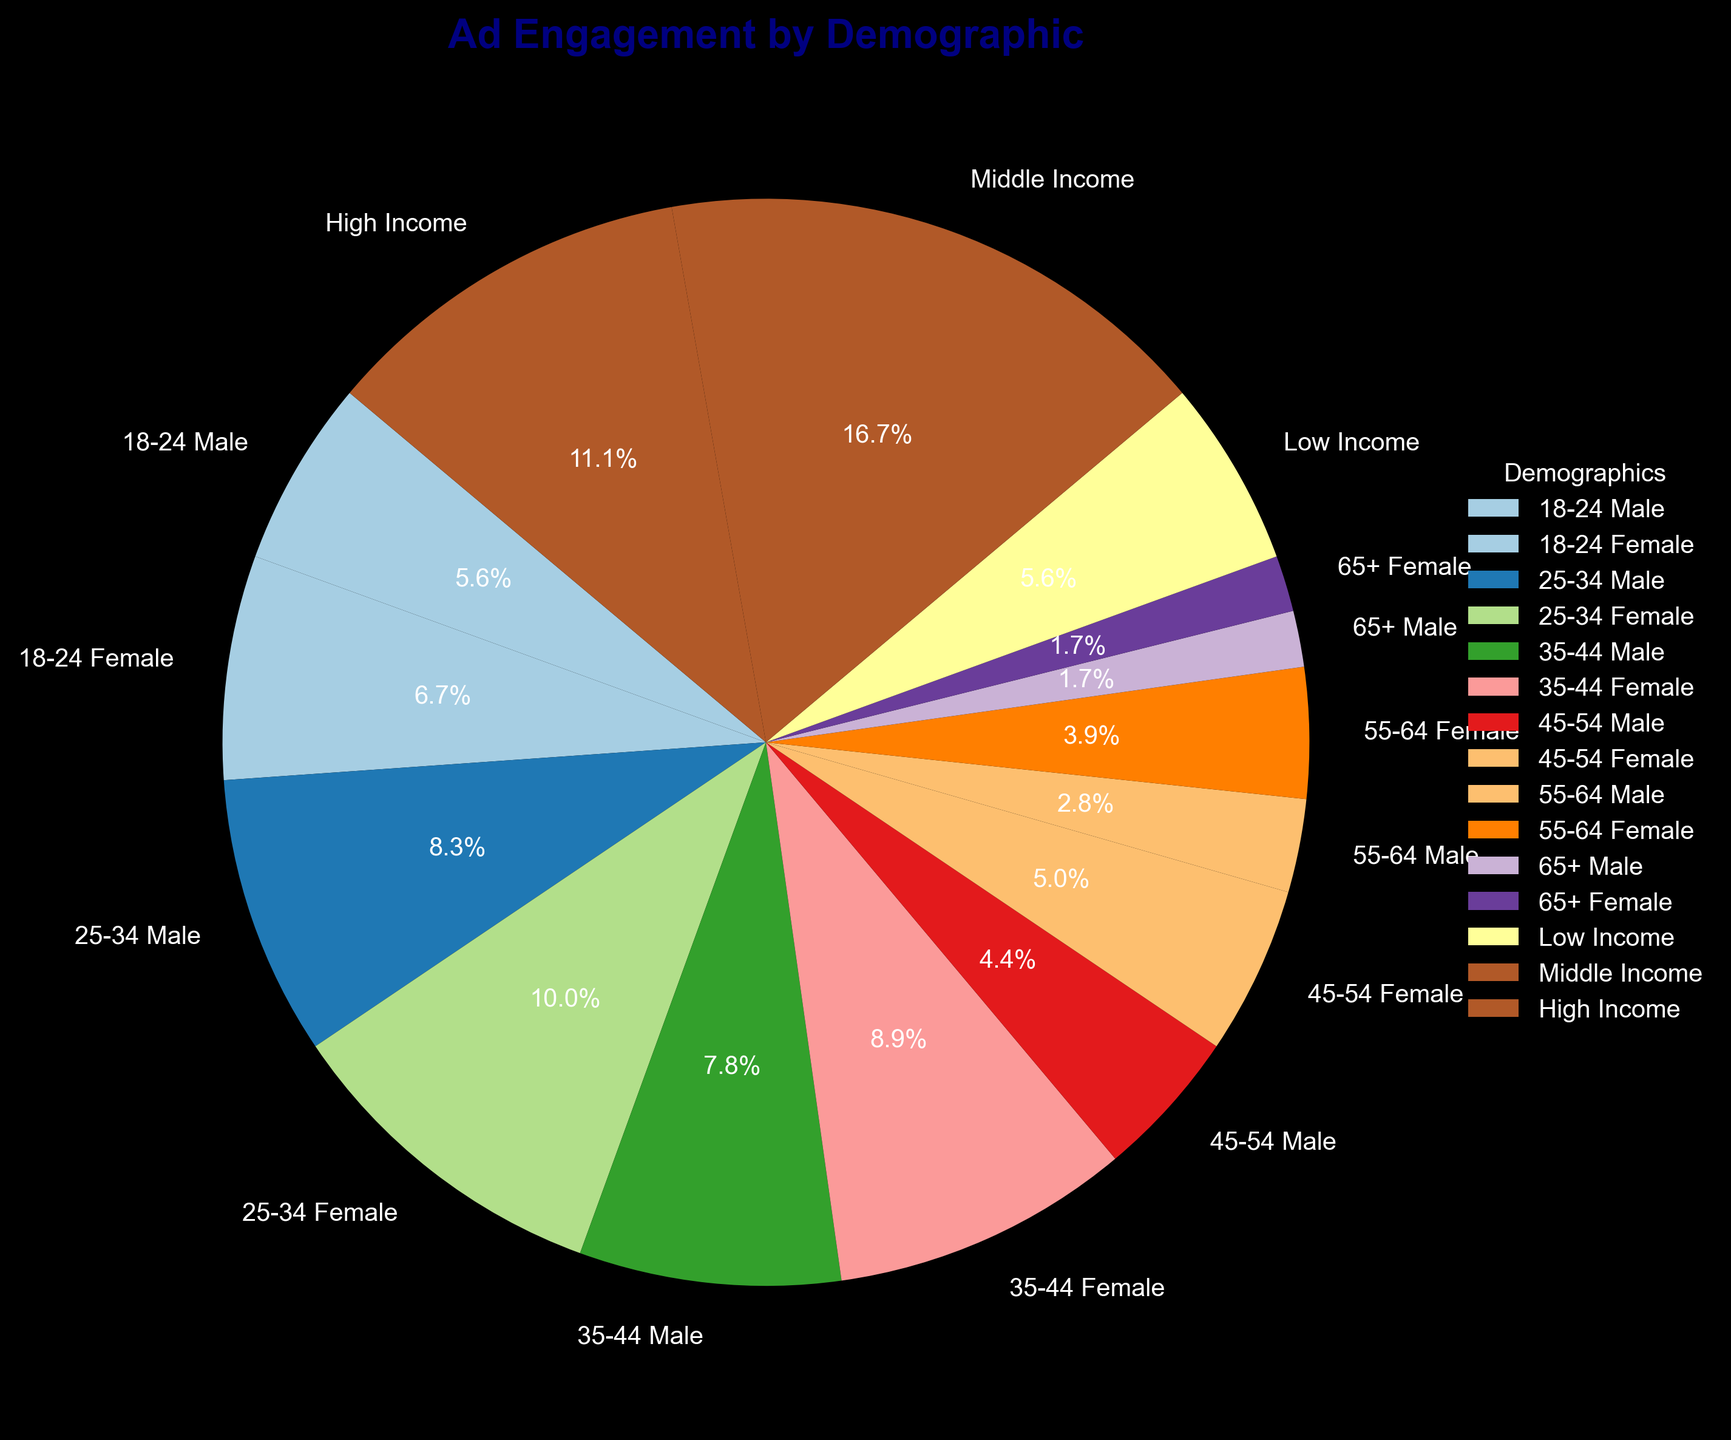Which demographic has the highest ad engagement? Identify the wedge with the largest percentage, which is "25-34 Female" with 18%.
Answer: 25-34 Female Which age group has the lowest ad engagement, and what is its percentage? Identify the age group and gender with the smallest wedge, which is "65+ Male" and "65+ Female", both with 3%.
Answer: 65+ Male and Female, 3% What's the combined ad engagement percentage for males aged 18-34? Sum up the percentage for "18-24 Male" (10%), "25-34 Male" (15%): 10% + 15% = 25%.
Answer: 25% How does the ad engagement of females aged 25-34 compare to that of females aged 35-44? Compare "25-34 Female" (18%) and "35-44 Female" (16%): 18% > 16%.
Answer: 25-34 Female has higher engagement What is the total percentage of ad engagement for females aged 18-44? Sum up percentages for "18-24 Female" (12%), "25-34 Female" (18%), and "35-44 Female" (16%): 12% + 18% + 16% = 46%.
Answer: 46% Compare the total ad engagement percentages of males and females. Sum up percentages for all male and female demographics: Males (58%) and Females (65%). Compare both sums: 58% < 65%.
Answer: Females have higher engagement What is the ad engagement percentage difference between the highest (25-34 Female) and the lowest (65+ Male) demographics? Calculate the percentage difference: 18% - 3% = 15%.
Answer: 15% What is the combined ad engagement for the "Low Income" and "High Income" groups? Sum up the percentage for "Low Income" (10%) and "High Income" (20%): 10% + 20% = 30%.
Answer: 30% What visual characteristic helps in easily identifying the demographic with 3% ad engagement? Identify the smallest wedges in the pie chart, corresponding to "65+ Male" and "65+ Female". Being the smallest pieces makes them distinctly noticeable.
Answer: Smallest wedges How does the ad engagement for Middle Income compare with the combined ad engagement of the 55-64 age group? Compare "Middle Income" (30%) with the sum of "55-64 Male" (5%) and "55-64 Female" (7%): 30% > (5% + 7% = 12%).
Answer: Middle Income is higher 